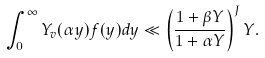<formula> <loc_0><loc_0><loc_500><loc_500>\int _ { 0 } ^ { \infty } Y _ { v } ( \alpha y ) f ( y ) d y \ll \left ( \frac { 1 + \beta Y } { 1 + \alpha Y } \right ) ^ { J } Y .</formula> 